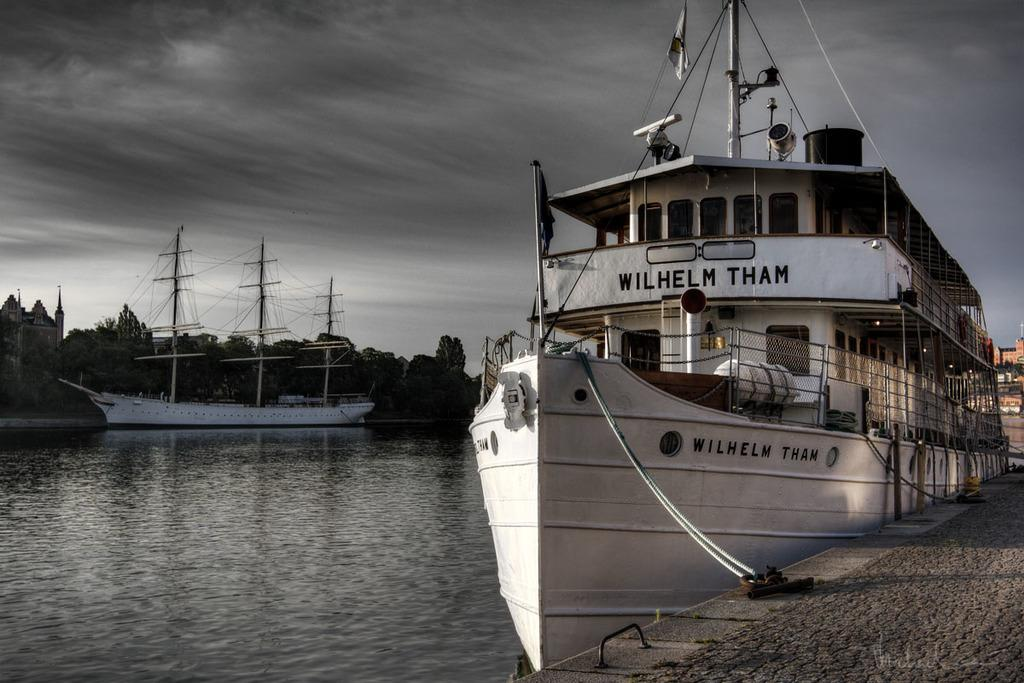What can be seen on the water in the image? There are ships on the water in the image. What type of vegetation is visible in the image? There are trees visible in the image. What type of structures can be seen in the image? There are buildings in the image. What surface is present in the image for people to stand or walk on? There is a deck in the image. What is visible above the land and water in the image? The sky is visible in the image, and clouds are present in the sky. Can you tell me how many times the property stretches in the image? There is no property mentioned in the image, and therefore no stretching can be observed. How many times does the person in the image bite the apple? There is no person or apple present in the image. 